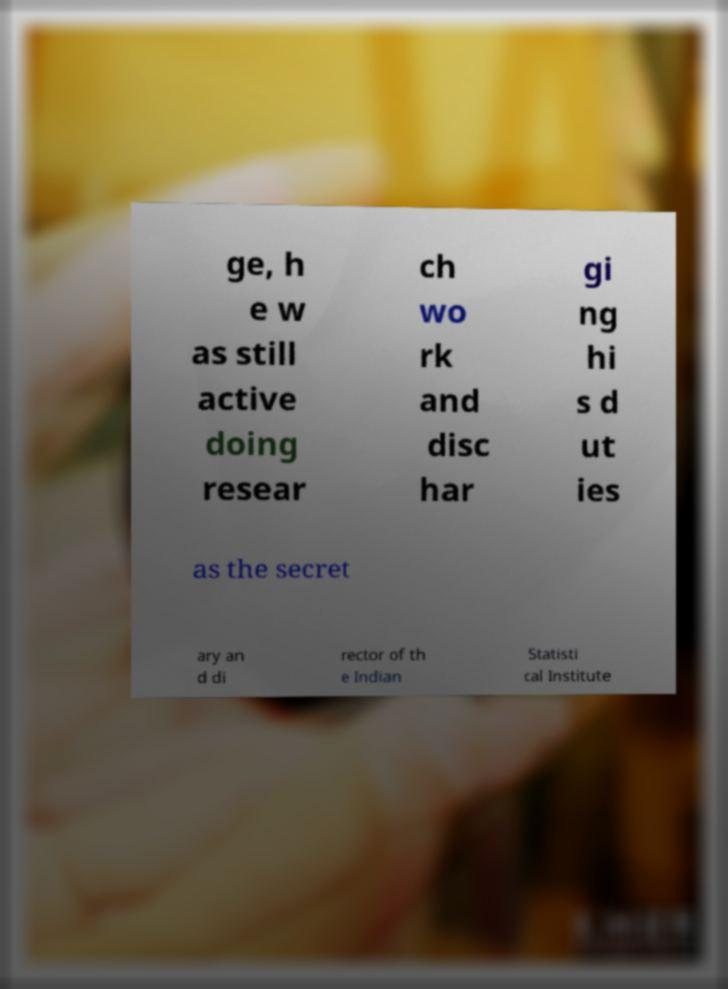Please identify and transcribe the text found in this image. ge, h e w as still active doing resear ch wo rk and disc har gi ng hi s d ut ies as the secret ary an d di rector of th e Indian Statisti cal Institute 